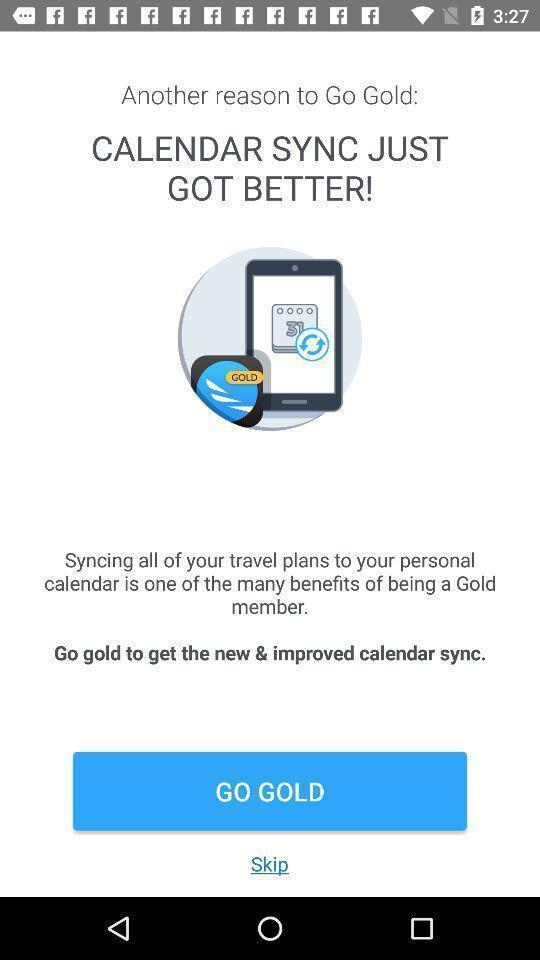Please provide a description for this image. Welcome page for a calendar application. 